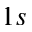Convert formula to latex. <formula><loc_0><loc_0><loc_500><loc_500>1 s</formula> 